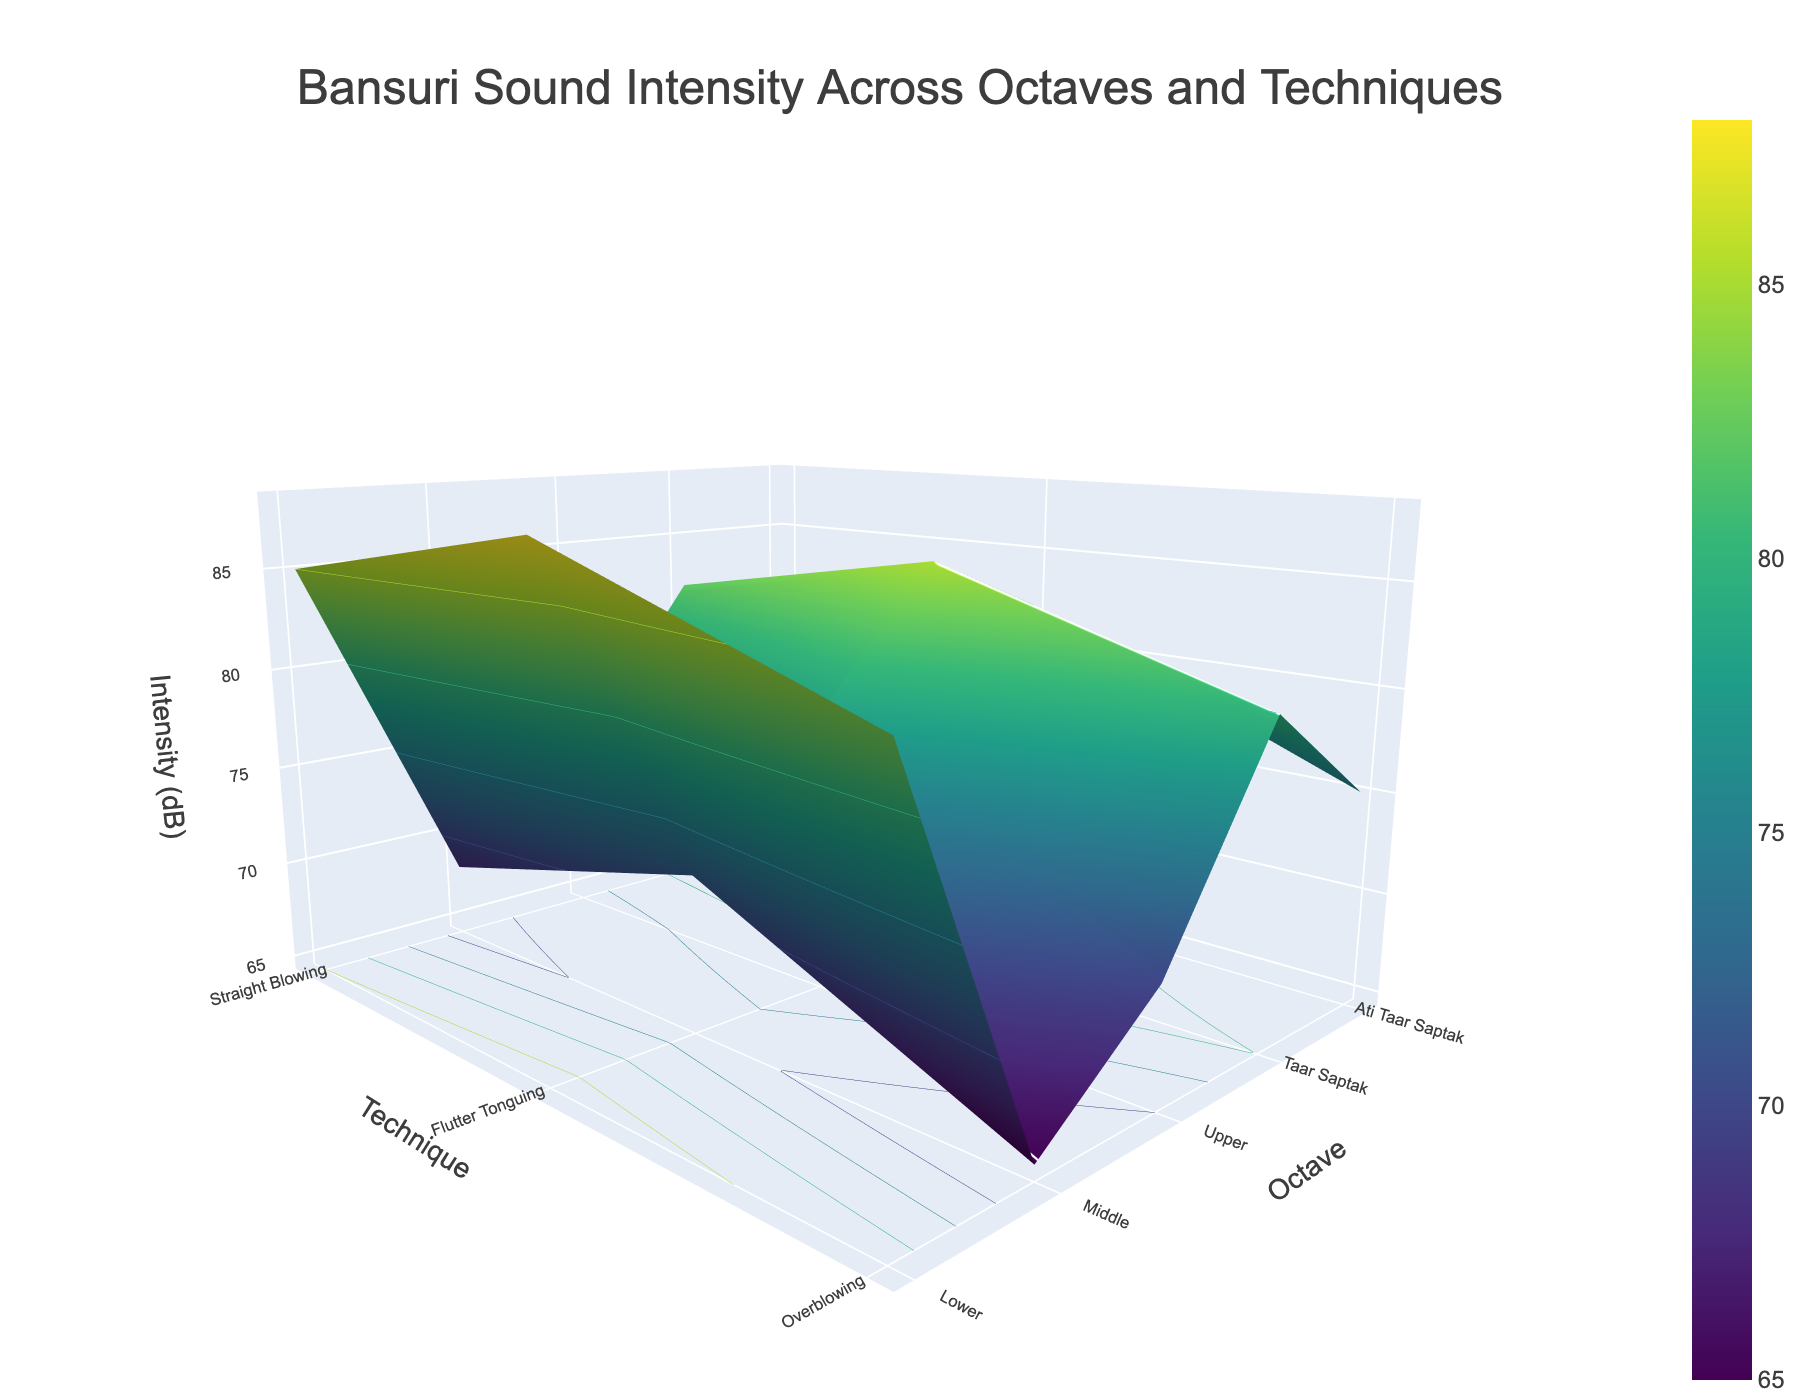What is the title of the 3D surface plot? The title is usually placed at the top of the plot and is used to describe what the data represents. In this figure, the title provides an overview of the analysis conducted.
Answer: Bansuri Sound Intensity Across Octaves and Techniques What are the axes labels in the plot? Axes labels describe the dimensions or variables plotted on each axis. In this plot, we have three axes, each representing different dimensions of the data.
Answer: Technique, Octave, Intensity (dB) Which octave and playing technique combination has the highest intensity? To find this, look at the highest point on the 3D surface plot, which represents the maximum value of sound intensity. Trace this peak to its corresponding octave and technique.
Answer: Ati Taar Saptak, Overblowing Compare the sound intensity in the Lower octave for Straight Blowing and Overblowing techniques. Locate the Lower octave on the y-axis and compare the values of sound intensity for Straight Blowing and Overblowing techniques.
Answer: 65 dB for Straight Blowing, 72 dB for Overblowing How does the intensity change as we move from Straight Blowing to Overblowing in the Middle octave? Start from Straight Blowing and move to Overblowing within the Middle octave, noting the change in sound intensity between these two techniques.
Answer: Increases from 70 dB to 78 dB What is the average sound intensity for Flutter Tonguing technique across all octaves? Identify the sound intensity values for Flutter Tonguing across all octaves and compute their average. The values are 68, 73, 77, 82, and 85 dB. Average is calculated by summing these values and dividing by the number of observations.
Answer: (68 + 73 + 77 + 82 + 85) / 5 = 77 dB What is the overall trend of sound intensity as we move from Lower to Ati Taar Saptak octave for the Overblowing technique? Examine the values of sound intensity for Overblowing as we progress from the Lower octave to the Ati Taar Saptak octave, observing how the intensity changes with each step.
Answer: Increases consistently Between the techniques in the Upper octave, which one has the lowest intensity and what is its value? Look at the sound intensity values within the Upper octave and identify which technique has the lowest value.
Answer: Straight Blowing, 75 dB Calculate the difference in sound intensity between the Taar Saptak and Lower octave for the Flutter Tonguing technique. Identify the sound intensity values for Flutter Tonguing in Taar Saptak and Lower octave, then subtract the value for the Lower octave from the value for Taar Saptak.
Answer: 82 dB - 68 dB = 14 dB How does the camera perspective affect the visualization of data in the 3D surface plot? The camera position in a 3D surface plot can significantly impact the visibility and interpretation of data points by providing different angles and depth perceptions. The current perspective in the provided plot gives a clear view of the intensity trend across techniques and octaves.
Answer: Emphasizes depth and trends across octaves and techniques 